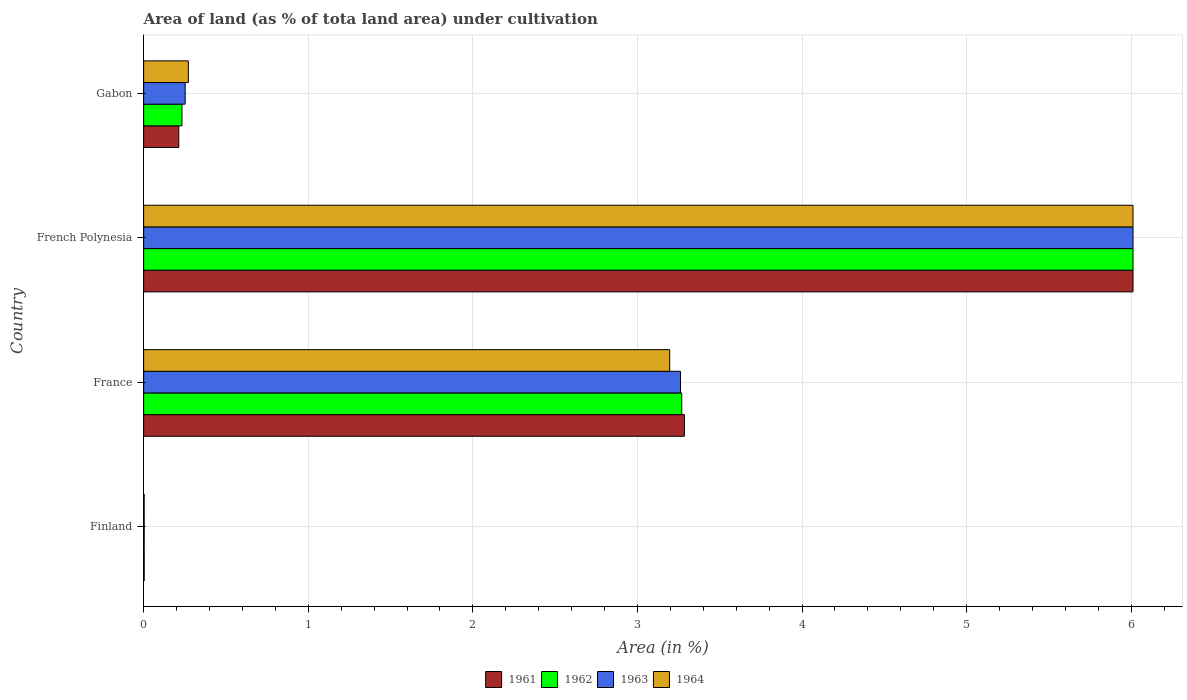Are the number of bars per tick equal to the number of legend labels?
Provide a succinct answer. Yes. How many bars are there on the 1st tick from the top?
Ensure brevity in your answer.  4. How many bars are there on the 2nd tick from the bottom?
Provide a succinct answer. 4. What is the label of the 1st group of bars from the top?
Provide a succinct answer. Gabon. In how many cases, is the number of bars for a given country not equal to the number of legend labels?
Give a very brief answer. 0. What is the percentage of land under cultivation in 1962 in Gabon?
Provide a succinct answer. 0.23. Across all countries, what is the maximum percentage of land under cultivation in 1964?
Keep it short and to the point. 6.01. Across all countries, what is the minimum percentage of land under cultivation in 1964?
Offer a very short reply. 0. In which country was the percentage of land under cultivation in 1961 maximum?
Your answer should be very brief. French Polynesia. What is the total percentage of land under cultivation in 1962 in the graph?
Offer a very short reply. 9.52. What is the difference between the percentage of land under cultivation in 1964 in French Polynesia and that in Gabon?
Keep it short and to the point. 5.74. What is the difference between the percentage of land under cultivation in 1962 in France and the percentage of land under cultivation in 1964 in Gabon?
Your answer should be very brief. 3. What is the average percentage of land under cultivation in 1961 per country?
Your response must be concise. 2.38. What is the difference between the percentage of land under cultivation in 1963 and percentage of land under cultivation in 1964 in France?
Your answer should be very brief. 0.07. In how many countries, is the percentage of land under cultivation in 1961 greater than 3.8 %?
Your answer should be compact. 1. What is the ratio of the percentage of land under cultivation in 1961 in France to that in Gabon?
Make the answer very short. 15.39. What is the difference between the highest and the second highest percentage of land under cultivation in 1964?
Make the answer very short. 2.81. What is the difference between the highest and the lowest percentage of land under cultivation in 1963?
Ensure brevity in your answer.  6.01. Is the sum of the percentage of land under cultivation in 1962 in Finland and France greater than the maximum percentage of land under cultivation in 1963 across all countries?
Ensure brevity in your answer.  No. Is it the case that in every country, the sum of the percentage of land under cultivation in 1963 and percentage of land under cultivation in 1964 is greater than the sum of percentage of land under cultivation in 1962 and percentage of land under cultivation in 1961?
Provide a short and direct response. No. What does the 1st bar from the top in Finland represents?
Offer a very short reply. 1964. Are all the bars in the graph horizontal?
Provide a succinct answer. Yes. How many countries are there in the graph?
Your response must be concise. 4. What is the difference between two consecutive major ticks on the X-axis?
Your answer should be compact. 1. What is the title of the graph?
Offer a very short reply. Area of land (as % of tota land area) under cultivation. Does "1963" appear as one of the legend labels in the graph?
Your answer should be very brief. Yes. What is the label or title of the X-axis?
Provide a short and direct response. Area (in %). What is the Area (in %) in 1961 in Finland?
Your response must be concise. 0. What is the Area (in %) of 1962 in Finland?
Your response must be concise. 0. What is the Area (in %) in 1963 in Finland?
Provide a succinct answer. 0. What is the Area (in %) in 1964 in Finland?
Your answer should be very brief. 0. What is the Area (in %) of 1961 in France?
Make the answer very short. 3.29. What is the Area (in %) in 1962 in France?
Ensure brevity in your answer.  3.27. What is the Area (in %) in 1963 in France?
Ensure brevity in your answer.  3.26. What is the Area (in %) in 1964 in France?
Offer a terse response. 3.2. What is the Area (in %) of 1961 in French Polynesia?
Keep it short and to the point. 6.01. What is the Area (in %) of 1962 in French Polynesia?
Keep it short and to the point. 6.01. What is the Area (in %) of 1963 in French Polynesia?
Your answer should be very brief. 6.01. What is the Area (in %) in 1964 in French Polynesia?
Your response must be concise. 6.01. What is the Area (in %) in 1961 in Gabon?
Make the answer very short. 0.21. What is the Area (in %) in 1962 in Gabon?
Ensure brevity in your answer.  0.23. What is the Area (in %) of 1963 in Gabon?
Your response must be concise. 0.25. What is the Area (in %) of 1964 in Gabon?
Provide a short and direct response. 0.27. Across all countries, what is the maximum Area (in %) of 1961?
Give a very brief answer. 6.01. Across all countries, what is the maximum Area (in %) in 1962?
Provide a succinct answer. 6.01. Across all countries, what is the maximum Area (in %) of 1963?
Make the answer very short. 6.01. Across all countries, what is the maximum Area (in %) of 1964?
Ensure brevity in your answer.  6.01. Across all countries, what is the minimum Area (in %) in 1961?
Provide a short and direct response. 0. Across all countries, what is the minimum Area (in %) in 1962?
Make the answer very short. 0. Across all countries, what is the minimum Area (in %) in 1963?
Your answer should be very brief. 0. Across all countries, what is the minimum Area (in %) of 1964?
Ensure brevity in your answer.  0. What is the total Area (in %) in 1961 in the graph?
Your response must be concise. 9.51. What is the total Area (in %) in 1962 in the graph?
Keep it short and to the point. 9.52. What is the total Area (in %) in 1963 in the graph?
Provide a short and direct response. 9.53. What is the total Area (in %) in 1964 in the graph?
Provide a short and direct response. 9.48. What is the difference between the Area (in %) in 1961 in Finland and that in France?
Provide a succinct answer. -3.28. What is the difference between the Area (in %) of 1962 in Finland and that in France?
Keep it short and to the point. -3.27. What is the difference between the Area (in %) in 1963 in Finland and that in France?
Offer a terse response. -3.26. What is the difference between the Area (in %) in 1964 in Finland and that in France?
Your response must be concise. -3.19. What is the difference between the Area (in %) of 1961 in Finland and that in French Polynesia?
Provide a short and direct response. -6.01. What is the difference between the Area (in %) in 1962 in Finland and that in French Polynesia?
Your answer should be very brief. -6.01. What is the difference between the Area (in %) of 1963 in Finland and that in French Polynesia?
Your answer should be very brief. -6.01. What is the difference between the Area (in %) in 1964 in Finland and that in French Polynesia?
Your response must be concise. -6.01. What is the difference between the Area (in %) in 1961 in Finland and that in Gabon?
Your answer should be very brief. -0.21. What is the difference between the Area (in %) in 1962 in Finland and that in Gabon?
Your answer should be very brief. -0.23. What is the difference between the Area (in %) of 1963 in Finland and that in Gabon?
Provide a succinct answer. -0.25. What is the difference between the Area (in %) of 1964 in Finland and that in Gabon?
Give a very brief answer. -0.27. What is the difference between the Area (in %) of 1961 in France and that in French Polynesia?
Offer a very short reply. -2.73. What is the difference between the Area (in %) in 1962 in France and that in French Polynesia?
Offer a terse response. -2.74. What is the difference between the Area (in %) of 1963 in France and that in French Polynesia?
Your answer should be very brief. -2.75. What is the difference between the Area (in %) in 1964 in France and that in French Polynesia?
Offer a terse response. -2.81. What is the difference between the Area (in %) in 1961 in France and that in Gabon?
Make the answer very short. 3.07. What is the difference between the Area (in %) of 1962 in France and that in Gabon?
Your response must be concise. 3.04. What is the difference between the Area (in %) of 1963 in France and that in Gabon?
Ensure brevity in your answer.  3.01. What is the difference between the Area (in %) in 1964 in France and that in Gabon?
Offer a very short reply. 2.92. What is the difference between the Area (in %) in 1961 in French Polynesia and that in Gabon?
Make the answer very short. 5.8. What is the difference between the Area (in %) of 1962 in French Polynesia and that in Gabon?
Offer a very short reply. 5.78. What is the difference between the Area (in %) in 1963 in French Polynesia and that in Gabon?
Your response must be concise. 5.76. What is the difference between the Area (in %) of 1964 in French Polynesia and that in Gabon?
Offer a very short reply. 5.74. What is the difference between the Area (in %) of 1961 in Finland and the Area (in %) of 1962 in France?
Offer a terse response. -3.27. What is the difference between the Area (in %) of 1961 in Finland and the Area (in %) of 1963 in France?
Give a very brief answer. -3.26. What is the difference between the Area (in %) in 1961 in Finland and the Area (in %) in 1964 in France?
Ensure brevity in your answer.  -3.19. What is the difference between the Area (in %) of 1962 in Finland and the Area (in %) of 1963 in France?
Give a very brief answer. -3.26. What is the difference between the Area (in %) of 1962 in Finland and the Area (in %) of 1964 in France?
Your answer should be very brief. -3.19. What is the difference between the Area (in %) in 1963 in Finland and the Area (in %) in 1964 in France?
Make the answer very short. -3.19. What is the difference between the Area (in %) of 1961 in Finland and the Area (in %) of 1962 in French Polynesia?
Provide a succinct answer. -6.01. What is the difference between the Area (in %) of 1961 in Finland and the Area (in %) of 1963 in French Polynesia?
Your answer should be compact. -6.01. What is the difference between the Area (in %) in 1961 in Finland and the Area (in %) in 1964 in French Polynesia?
Your answer should be compact. -6.01. What is the difference between the Area (in %) in 1962 in Finland and the Area (in %) in 1963 in French Polynesia?
Give a very brief answer. -6.01. What is the difference between the Area (in %) of 1962 in Finland and the Area (in %) of 1964 in French Polynesia?
Offer a very short reply. -6.01. What is the difference between the Area (in %) in 1963 in Finland and the Area (in %) in 1964 in French Polynesia?
Give a very brief answer. -6.01. What is the difference between the Area (in %) in 1961 in Finland and the Area (in %) in 1962 in Gabon?
Provide a succinct answer. -0.23. What is the difference between the Area (in %) of 1961 in Finland and the Area (in %) of 1963 in Gabon?
Offer a terse response. -0.25. What is the difference between the Area (in %) of 1961 in Finland and the Area (in %) of 1964 in Gabon?
Give a very brief answer. -0.27. What is the difference between the Area (in %) of 1962 in Finland and the Area (in %) of 1963 in Gabon?
Give a very brief answer. -0.25. What is the difference between the Area (in %) in 1962 in Finland and the Area (in %) in 1964 in Gabon?
Offer a terse response. -0.27. What is the difference between the Area (in %) of 1963 in Finland and the Area (in %) of 1964 in Gabon?
Your response must be concise. -0.27. What is the difference between the Area (in %) in 1961 in France and the Area (in %) in 1962 in French Polynesia?
Provide a succinct answer. -2.73. What is the difference between the Area (in %) of 1961 in France and the Area (in %) of 1963 in French Polynesia?
Provide a succinct answer. -2.73. What is the difference between the Area (in %) of 1961 in France and the Area (in %) of 1964 in French Polynesia?
Keep it short and to the point. -2.73. What is the difference between the Area (in %) of 1962 in France and the Area (in %) of 1963 in French Polynesia?
Your answer should be very brief. -2.74. What is the difference between the Area (in %) of 1962 in France and the Area (in %) of 1964 in French Polynesia?
Provide a short and direct response. -2.74. What is the difference between the Area (in %) in 1963 in France and the Area (in %) in 1964 in French Polynesia?
Provide a succinct answer. -2.75. What is the difference between the Area (in %) of 1961 in France and the Area (in %) of 1962 in Gabon?
Your response must be concise. 3.05. What is the difference between the Area (in %) in 1961 in France and the Area (in %) in 1963 in Gabon?
Offer a very short reply. 3.03. What is the difference between the Area (in %) of 1961 in France and the Area (in %) of 1964 in Gabon?
Your answer should be compact. 3.01. What is the difference between the Area (in %) of 1962 in France and the Area (in %) of 1963 in Gabon?
Your response must be concise. 3.02. What is the difference between the Area (in %) in 1962 in France and the Area (in %) in 1964 in Gabon?
Your answer should be compact. 3. What is the difference between the Area (in %) in 1963 in France and the Area (in %) in 1964 in Gabon?
Provide a short and direct response. 2.99. What is the difference between the Area (in %) in 1961 in French Polynesia and the Area (in %) in 1962 in Gabon?
Keep it short and to the point. 5.78. What is the difference between the Area (in %) in 1961 in French Polynesia and the Area (in %) in 1963 in Gabon?
Provide a succinct answer. 5.76. What is the difference between the Area (in %) of 1961 in French Polynesia and the Area (in %) of 1964 in Gabon?
Ensure brevity in your answer.  5.74. What is the difference between the Area (in %) of 1962 in French Polynesia and the Area (in %) of 1963 in Gabon?
Ensure brevity in your answer.  5.76. What is the difference between the Area (in %) of 1962 in French Polynesia and the Area (in %) of 1964 in Gabon?
Give a very brief answer. 5.74. What is the difference between the Area (in %) of 1963 in French Polynesia and the Area (in %) of 1964 in Gabon?
Offer a terse response. 5.74. What is the average Area (in %) in 1961 per country?
Give a very brief answer. 2.38. What is the average Area (in %) of 1962 per country?
Your response must be concise. 2.38. What is the average Area (in %) in 1963 per country?
Offer a very short reply. 2.38. What is the average Area (in %) in 1964 per country?
Offer a terse response. 2.37. What is the difference between the Area (in %) in 1961 and Area (in %) in 1962 in Finland?
Make the answer very short. 0. What is the difference between the Area (in %) in 1961 and Area (in %) in 1964 in Finland?
Your answer should be compact. 0. What is the difference between the Area (in %) of 1962 and Area (in %) of 1964 in Finland?
Your answer should be compact. 0. What is the difference between the Area (in %) of 1963 and Area (in %) of 1964 in Finland?
Offer a very short reply. 0. What is the difference between the Area (in %) of 1961 and Area (in %) of 1962 in France?
Your answer should be very brief. 0.02. What is the difference between the Area (in %) in 1961 and Area (in %) in 1963 in France?
Ensure brevity in your answer.  0.02. What is the difference between the Area (in %) of 1961 and Area (in %) of 1964 in France?
Your answer should be compact. 0.09. What is the difference between the Area (in %) of 1962 and Area (in %) of 1963 in France?
Keep it short and to the point. 0.01. What is the difference between the Area (in %) of 1962 and Area (in %) of 1964 in France?
Offer a very short reply. 0.07. What is the difference between the Area (in %) in 1963 and Area (in %) in 1964 in France?
Your answer should be very brief. 0.07. What is the difference between the Area (in %) in 1961 and Area (in %) in 1963 in French Polynesia?
Ensure brevity in your answer.  0. What is the difference between the Area (in %) in 1961 and Area (in %) in 1964 in French Polynesia?
Your answer should be very brief. 0. What is the difference between the Area (in %) in 1962 and Area (in %) in 1963 in French Polynesia?
Give a very brief answer. 0. What is the difference between the Area (in %) of 1962 and Area (in %) of 1964 in French Polynesia?
Your answer should be compact. 0. What is the difference between the Area (in %) in 1961 and Area (in %) in 1962 in Gabon?
Offer a very short reply. -0.02. What is the difference between the Area (in %) in 1961 and Area (in %) in 1963 in Gabon?
Your response must be concise. -0.04. What is the difference between the Area (in %) of 1961 and Area (in %) of 1964 in Gabon?
Provide a short and direct response. -0.06. What is the difference between the Area (in %) in 1962 and Area (in %) in 1963 in Gabon?
Ensure brevity in your answer.  -0.02. What is the difference between the Area (in %) of 1962 and Area (in %) of 1964 in Gabon?
Offer a terse response. -0.04. What is the difference between the Area (in %) in 1963 and Area (in %) in 1964 in Gabon?
Make the answer very short. -0.02. What is the ratio of the Area (in %) of 1961 in Finland to that in France?
Offer a very short reply. 0. What is the ratio of the Area (in %) of 1964 in Finland to that in France?
Give a very brief answer. 0. What is the ratio of the Area (in %) of 1961 in Finland to that in French Polynesia?
Provide a succinct answer. 0. What is the ratio of the Area (in %) in 1962 in Finland to that in French Polynesia?
Your response must be concise. 0. What is the ratio of the Area (in %) in 1961 in Finland to that in Gabon?
Your response must be concise. 0.02. What is the ratio of the Area (in %) of 1962 in Finland to that in Gabon?
Provide a succinct answer. 0.01. What is the ratio of the Area (in %) of 1963 in Finland to that in Gabon?
Provide a short and direct response. 0.01. What is the ratio of the Area (in %) in 1964 in Finland to that in Gabon?
Ensure brevity in your answer.  0.01. What is the ratio of the Area (in %) of 1961 in France to that in French Polynesia?
Your response must be concise. 0.55. What is the ratio of the Area (in %) in 1962 in France to that in French Polynesia?
Your response must be concise. 0.54. What is the ratio of the Area (in %) of 1963 in France to that in French Polynesia?
Provide a succinct answer. 0.54. What is the ratio of the Area (in %) of 1964 in France to that in French Polynesia?
Give a very brief answer. 0.53. What is the ratio of the Area (in %) in 1961 in France to that in Gabon?
Offer a very short reply. 15.39. What is the ratio of the Area (in %) of 1962 in France to that in Gabon?
Make the answer very short. 14.04. What is the ratio of the Area (in %) of 1963 in France to that in Gabon?
Offer a very short reply. 12.93. What is the ratio of the Area (in %) in 1964 in France to that in Gabon?
Ensure brevity in your answer.  11.76. What is the ratio of the Area (in %) in 1961 in French Polynesia to that in Gabon?
Your answer should be very brief. 28.16. What is the ratio of the Area (in %) in 1962 in French Polynesia to that in Gabon?
Make the answer very short. 25.81. What is the ratio of the Area (in %) of 1963 in French Polynesia to that in Gabon?
Keep it short and to the point. 23.83. What is the ratio of the Area (in %) in 1964 in French Polynesia to that in Gabon?
Provide a succinct answer. 22.13. What is the difference between the highest and the second highest Area (in %) of 1961?
Provide a short and direct response. 2.73. What is the difference between the highest and the second highest Area (in %) in 1962?
Your answer should be very brief. 2.74. What is the difference between the highest and the second highest Area (in %) of 1963?
Make the answer very short. 2.75. What is the difference between the highest and the second highest Area (in %) in 1964?
Provide a succinct answer. 2.81. What is the difference between the highest and the lowest Area (in %) of 1961?
Give a very brief answer. 6.01. What is the difference between the highest and the lowest Area (in %) of 1962?
Make the answer very short. 6.01. What is the difference between the highest and the lowest Area (in %) of 1963?
Your answer should be very brief. 6.01. What is the difference between the highest and the lowest Area (in %) of 1964?
Your answer should be very brief. 6.01. 